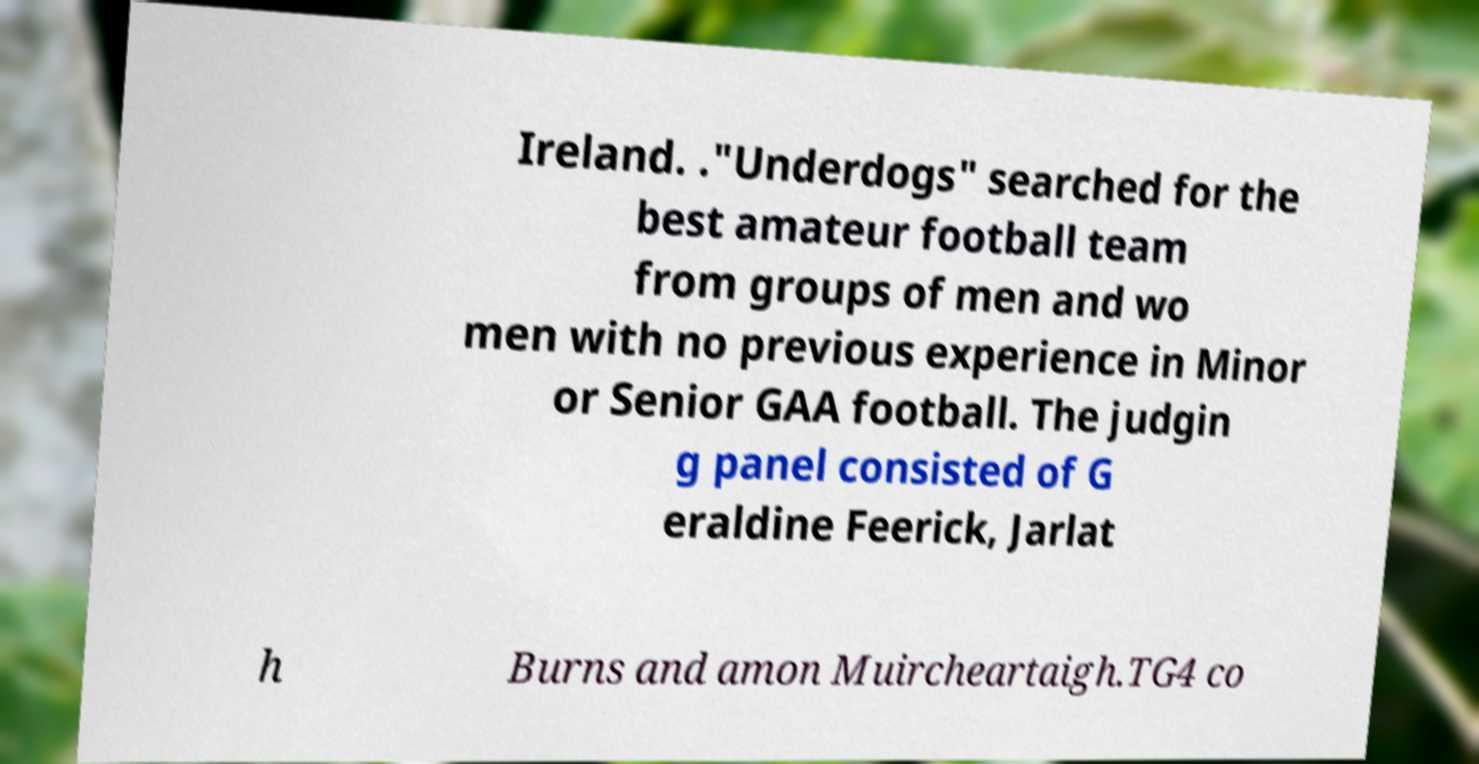Can you accurately transcribe the text from the provided image for me? Ireland. ."Underdogs" searched for the best amateur football team from groups of men and wo men with no previous experience in Minor or Senior GAA football. The judgin g panel consisted of G eraldine Feerick, Jarlat h Burns and amon Muircheartaigh.TG4 co 